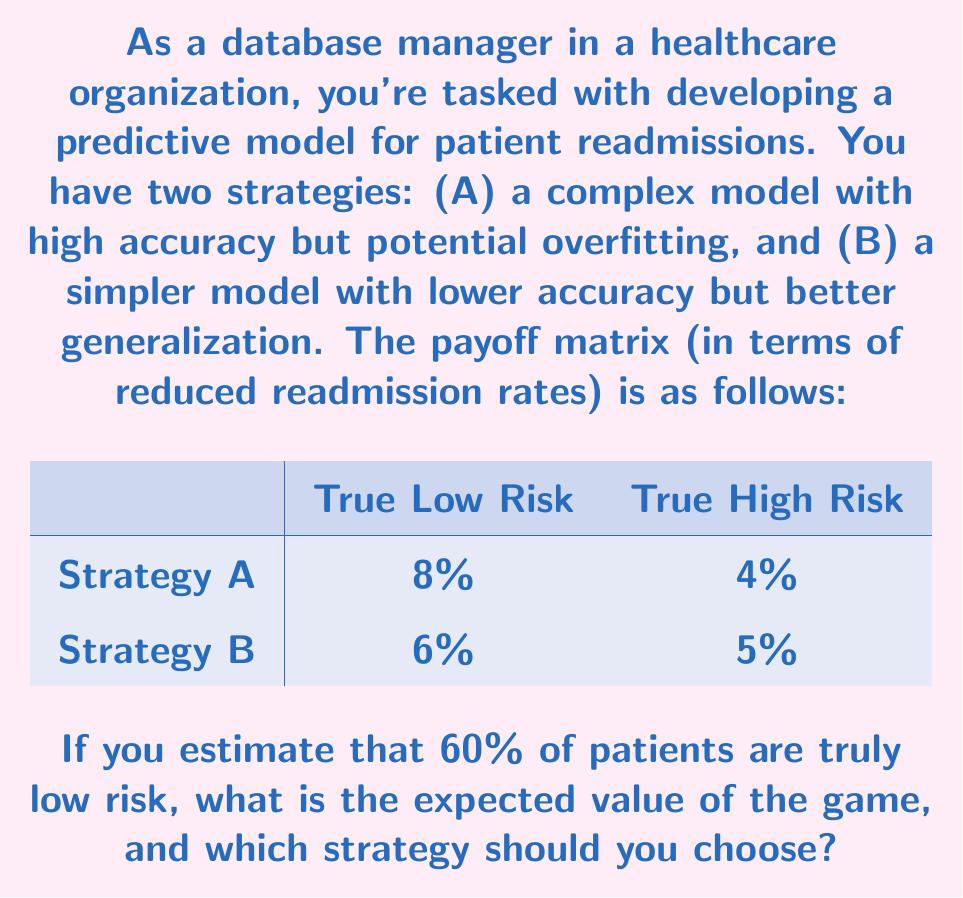What is the answer to this math problem? To solve this problem, we'll use the concept of expected value from game theory. Here's a step-by-step approach:

1) First, let's calculate the expected value for each strategy:

   For Strategy A:
   $E(A) = 0.60 \cdot 8\% + 0.40 \cdot 4\% = 4.8\% + 1.6\% = 6.4\%$

   For Strategy B:
   $E(B) = 0.60 \cdot 6\% + 0.40 \cdot 5\% = 3.6\% + 2.0\% = 5.6\%$

2) The expected value of the game is the maximum of these two values:

   $E(\text{game}) = \max(E(A), E(B)) = \max(6.4\%, 5.6\%) = 6.4\%$

3) Since $E(A) > E(B)$, Strategy A is the optimal choice.

This result demonstrates the risk-reward trade-off in predictive modeling. Strategy A, despite its potential for overfitting, offers a higher expected reduction in readmission rates. However, it's important to note that this decision is based on the assumption that 60% of patients are truly low risk. In practice, you would need to carefully validate this assumption and consider other factors such as model interpretability and long-term performance.
Answer: The expected value of the game is 6.4%, and Strategy A (the complex model) should be chosen. 